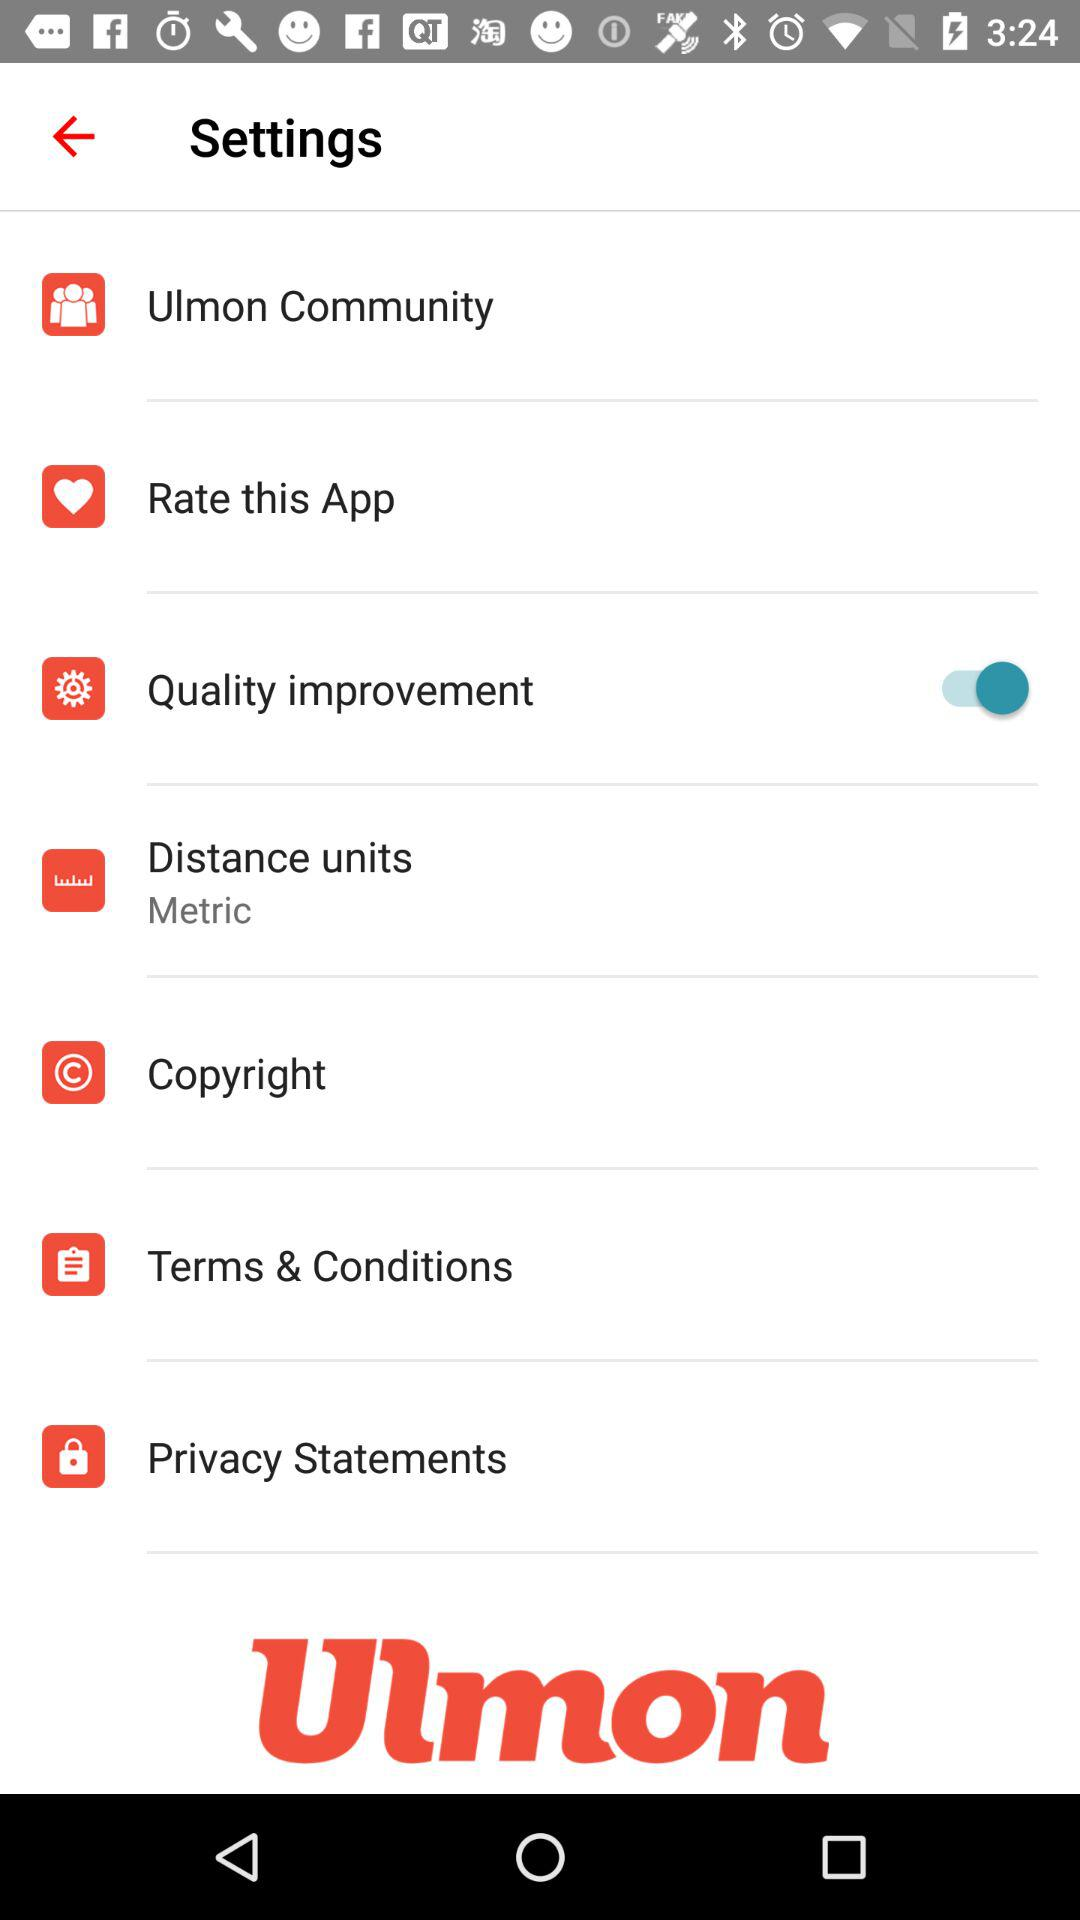What is the status of "Quality improvement"? The status is "on". 